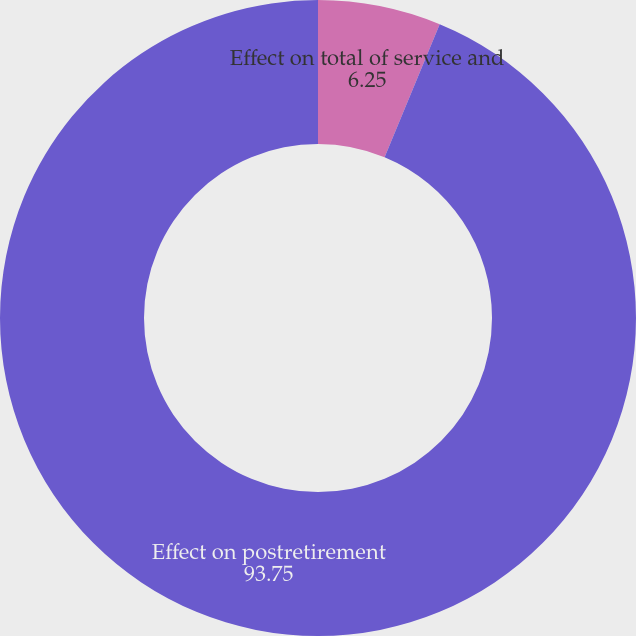Convert chart to OTSL. <chart><loc_0><loc_0><loc_500><loc_500><pie_chart><fcel>Effect on total of service and<fcel>Effect on postretirement<nl><fcel>6.25%<fcel>93.75%<nl></chart> 